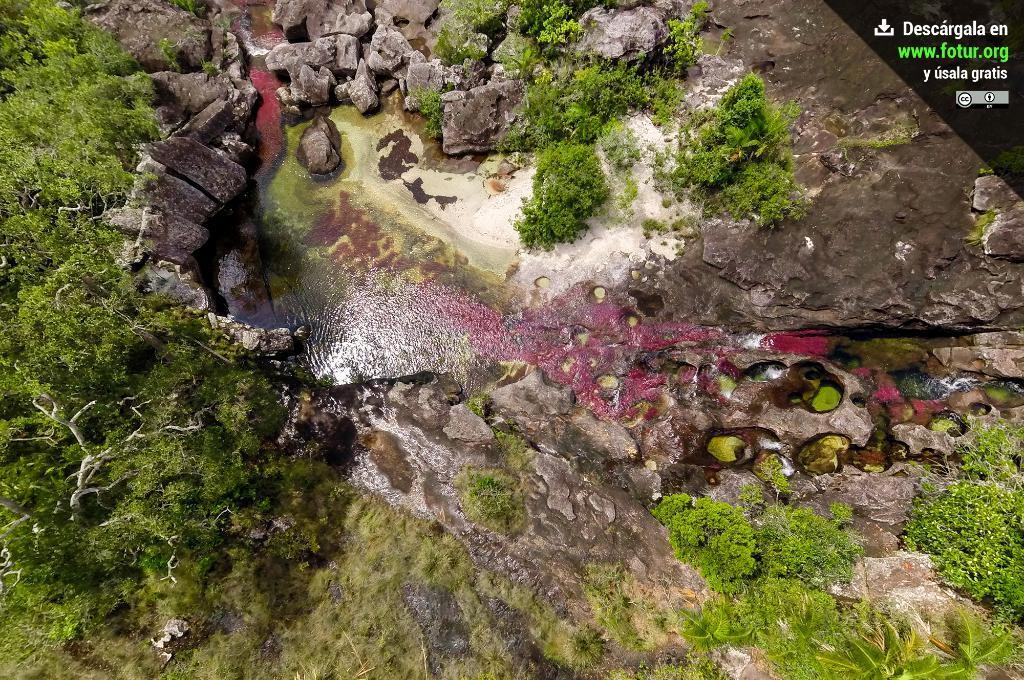What is the main feature of the image? There is a pond of water in the image. What surrounds the pond of water? There are rocks and trees around the water in the image. What is the income of the actor standing near the pond in the image? There is no actor present in the image, and therefore no income can be determined. 